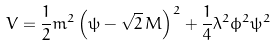<formula> <loc_0><loc_0><loc_500><loc_500>V = \frac { 1 } { 2 } m ^ { 2 } \left ( \psi - \sqrt { 2 } \, M \right ) ^ { 2 } + \frac { 1 } { 4 } \lambda ^ { 2 } \phi ^ { 2 } \psi ^ { 2 }</formula> 